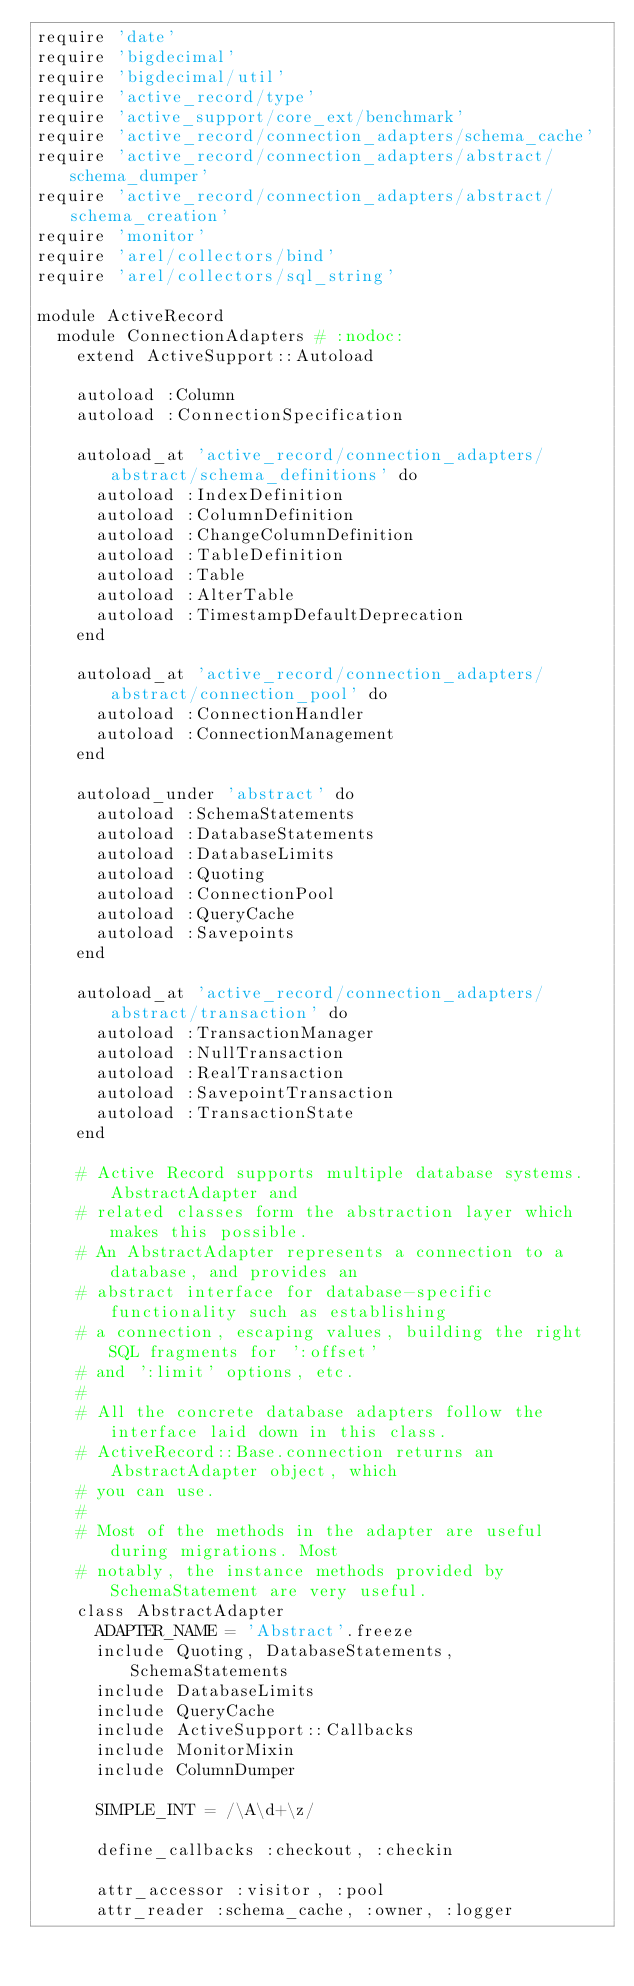<code> <loc_0><loc_0><loc_500><loc_500><_Ruby_>require 'date'
require 'bigdecimal'
require 'bigdecimal/util'
require 'active_record/type'
require 'active_support/core_ext/benchmark'
require 'active_record/connection_adapters/schema_cache'
require 'active_record/connection_adapters/abstract/schema_dumper'
require 'active_record/connection_adapters/abstract/schema_creation'
require 'monitor'
require 'arel/collectors/bind'
require 'arel/collectors/sql_string'

module ActiveRecord
  module ConnectionAdapters # :nodoc:
    extend ActiveSupport::Autoload

    autoload :Column
    autoload :ConnectionSpecification

    autoload_at 'active_record/connection_adapters/abstract/schema_definitions' do
      autoload :IndexDefinition
      autoload :ColumnDefinition
      autoload :ChangeColumnDefinition
      autoload :TableDefinition
      autoload :Table
      autoload :AlterTable
      autoload :TimestampDefaultDeprecation
    end

    autoload_at 'active_record/connection_adapters/abstract/connection_pool' do
      autoload :ConnectionHandler
      autoload :ConnectionManagement
    end

    autoload_under 'abstract' do
      autoload :SchemaStatements
      autoload :DatabaseStatements
      autoload :DatabaseLimits
      autoload :Quoting
      autoload :ConnectionPool
      autoload :QueryCache
      autoload :Savepoints
    end

    autoload_at 'active_record/connection_adapters/abstract/transaction' do
      autoload :TransactionManager
      autoload :NullTransaction
      autoload :RealTransaction
      autoload :SavepointTransaction
      autoload :TransactionState
    end

    # Active Record supports multiple database systems. AbstractAdapter and
    # related classes form the abstraction layer which makes this possible.
    # An AbstractAdapter represents a connection to a database, and provides an
    # abstract interface for database-specific functionality such as establishing
    # a connection, escaping values, building the right SQL fragments for ':offset'
    # and ':limit' options, etc.
    #
    # All the concrete database adapters follow the interface laid down in this class.
    # ActiveRecord::Base.connection returns an AbstractAdapter object, which
    # you can use.
    #
    # Most of the methods in the adapter are useful during migrations. Most
    # notably, the instance methods provided by SchemaStatement are very useful.
    class AbstractAdapter
      ADAPTER_NAME = 'Abstract'.freeze
      include Quoting, DatabaseStatements, SchemaStatements
      include DatabaseLimits
      include QueryCache
      include ActiveSupport::Callbacks
      include MonitorMixin
      include ColumnDumper

      SIMPLE_INT = /\A\d+\z/

      define_callbacks :checkout, :checkin

      attr_accessor :visitor, :pool
      attr_reader :schema_cache, :owner, :logger</code> 